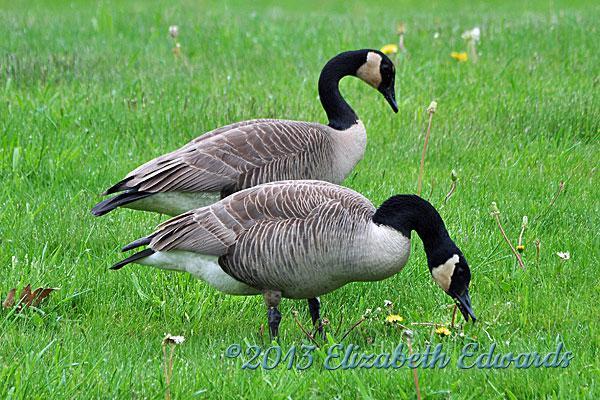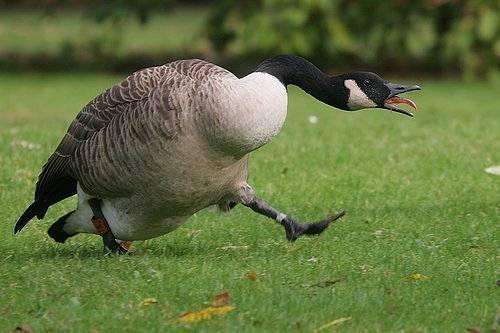The first image is the image on the left, the second image is the image on the right. For the images shown, is this caption "There are a handful of goslings (baby geese) in the left image." true? Answer yes or no. No. The first image is the image on the left, the second image is the image on the right. Given the left and right images, does the statement "There are at least two baby geese." hold true? Answer yes or no. No. 